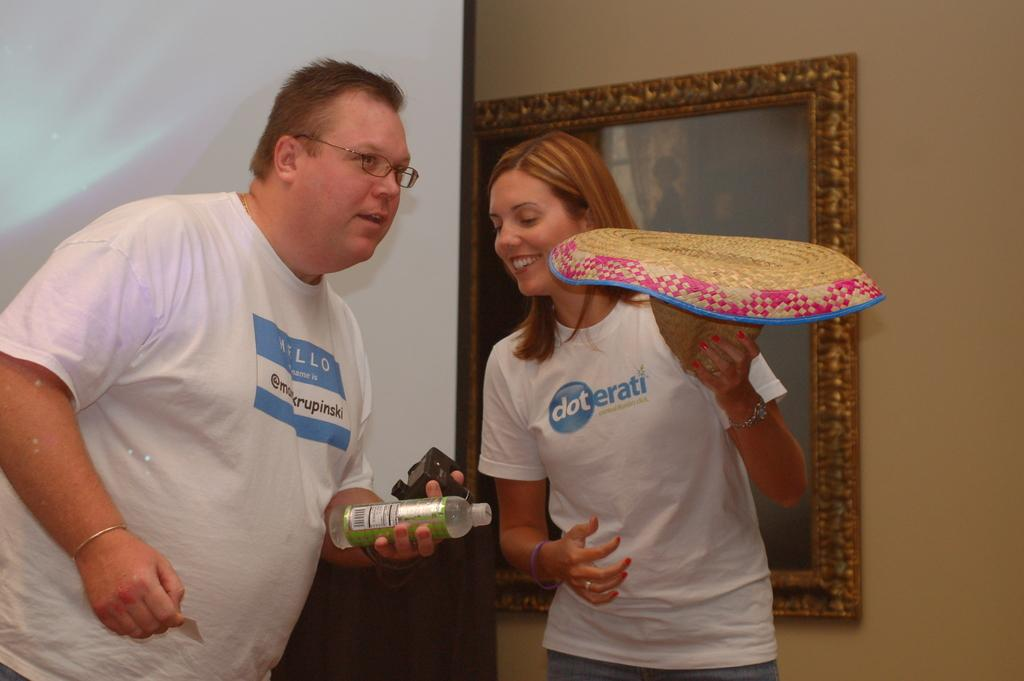Who is present in the image? There is a man and a woman in the image. What are the expressions on their faces? Both the man and woman are smiling in the image. What is the man holding in his left hand? The man is holding a water bottle in his left hand. What type of silk fabric is draped over the coach in the image? There is no coach or silk fabric present in the image. What phase is the moon in during the scene depicted in the image? The image does not show the moon or any indication of the moon's phase. 